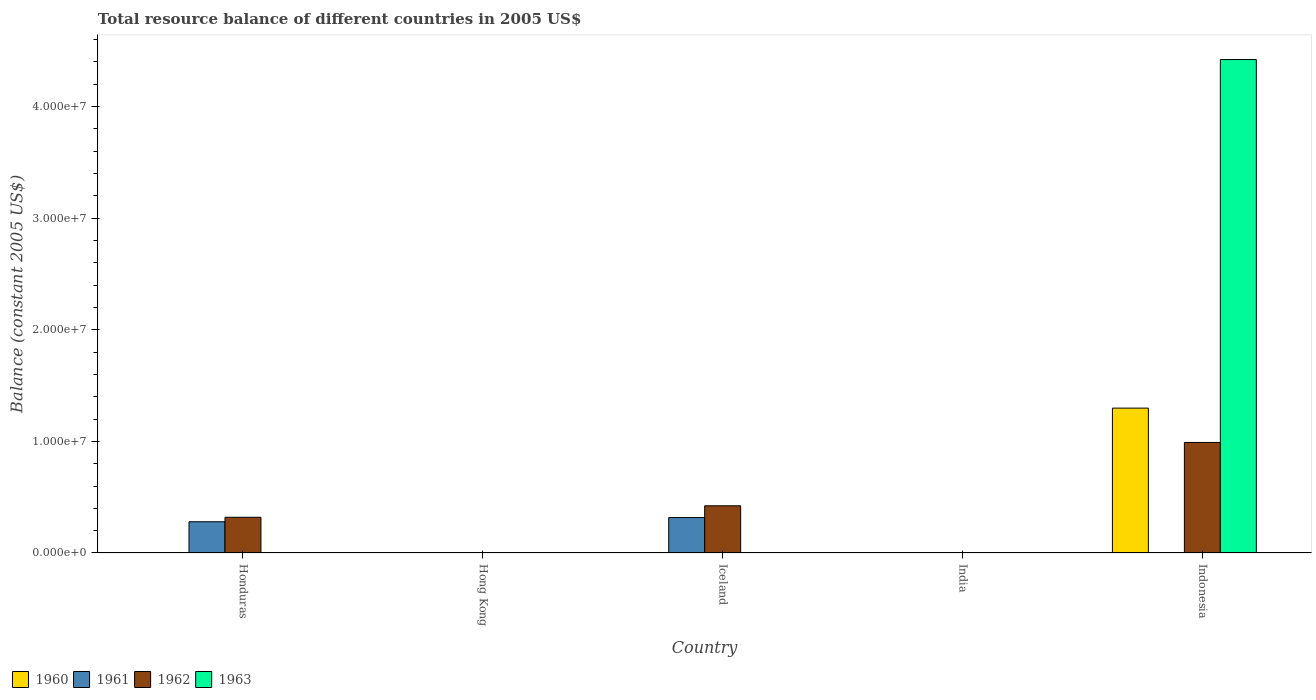How many different coloured bars are there?
Provide a short and direct response. 4. Are the number of bars per tick equal to the number of legend labels?
Ensure brevity in your answer.  No. How many bars are there on the 4th tick from the left?
Your answer should be compact. 0. What is the label of the 5th group of bars from the left?
Offer a very short reply. Indonesia. In how many cases, is the number of bars for a given country not equal to the number of legend labels?
Your response must be concise. 5. What is the total resource balance in 1961 in Honduras?
Give a very brief answer. 2.80e+06. Across all countries, what is the maximum total resource balance in 1960?
Your answer should be compact. 1.30e+07. What is the total total resource balance in 1960 in the graph?
Your response must be concise. 1.30e+07. What is the difference between the total resource balance in 1962 in Honduras and that in Indonesia?
Your response must be concise. -6.70e+06. What is the difference between the total resource balance in 1962 in Indonesia and the total resource balance in 1961 in Honduras?
Provide a short and direct response. 7.10e+06. What is the average total resource balance in 1961 per country?
Your response must be concise. 1.19e+06. What is the difference between the total resource balance of/in 1960 and total resource balance of/in 1962 in Indonesia?
Provide a short and direct response. 3.08e+06. Is the total resource balance in 1962 in Iceland less than that in Indonesia?
Offer a terse response. Yes. What is the difference between the highest and the second highest total resource balance in 1962?
Keep it short and to the point. 5.68e+06. What is the difference between the highest and the lowest total resource balance in 1962?
Your answer should be very brief. 9.90e+06. Is it the case that in every country, the sum of the total resource balance in 1961 and total resource balance in 1960 is greater than the total resource balance in 1963?
Provide a succinct answer. No. How many bars are there?
Provide a short and direct response. 7. Are all the bars in the graph horizontal?
Provide a short and direct response. No. Does the graph contain any zero values?
Provide a short and direct response. Yes. Where does the legend appear in the graph?
Make the answer very short. Bottom left. How many legend labels are there?
Offer a very short reply. 4. What is the title of the graph?
Keep it short and to the point. Total resource balance of different countries in 2005 US$. What is the label or title of the Y-axis?
Provide a short and direct response. Balance (constant 2005 US$). What is the Balance (constant 2005 US$) in 1960 in Honduras?
Make the answer very short. 0. What is the Balance (constant 2005 US$) of 1961 in Honduras?
Give a very brief answer. 2.80e+06. What is the Balance (constant 2005 US$) of 1962 in Honduras?
Provide a short and direct response. 3.20e+06. What is the Balance (constant 2005 US$) in 1961 in Hong Kong?
Your answer should be very brief. 0. What is the Balance (constant 2005 US$) of 1962 in Hong Kong?
Your response must be concise. 0. What is the Balance (constant 2005 US$) of 1963 in Hong Kong?
Ensure brevity in your answer.  0. What is the Balance (constant 2005 US$) of 1961 in Iceland?
Your answer should be compact. 3.17e+06. What is the Balance (constant 2005 US$) of 1962 in Iceland?
Keep it short and to the point. 4.23e+06. What is the Balance (constant 2005 US$) in 1963 in Iceland?
Give a very brief answer. 0. What is the Balance (constant 2005 US$) in 1960 in India?
Your answer should be very brief. 0. What is the Balance (constant 2005 US$) of 1961 in India?
Your answer should be very brief. 0. What is the Balance (constant 2005 US$) of 1962 in India?
Your response must be concise. 0. What is the Balance (constant 2005 US$) in 1963 in India?
Your answer should be compact. 0. What is the Balance (constant 2005 US$) of 1960 in Indonesia?
Provide a short and direct response. 1.30e+07. What is the Balance (constant 2005 US$) of 1961 in Indonesia?
Provide a short and direct response. 0. What is the Balance (constant 2005 US$) of 1962 in Indonesia?
Your response must be concise. 9.90e+06. What is the Balance (constant 2005 US$) in 1963 in Indonesia?
Make the answer very short. 4.42e+07. Across all countries, what is the maximum Balance (constant 2005 US$) of 1960?
Your answer should be very brief. 1.30e+07. Across all countries, what is the maximum Balance (constant 2005 US$) of 1961?
Your answer should be very brief. 3.17e+06. Across all countries, what is the maximum Balance (constant 2005 US$) of 1962?
Make the answer very short. 9.90e+06. Across all countries, what is the maximum Balance (constant 2005 US$) in 1963?
Offer a very short reply. 4.42e+07. Across all countries, what is the minimum Balance (constant 2005 US$) of 1960?
Give a very brief answer. 0. Across all countries, what is the minimum Balance (constant 2005 US$) in 1963?
Make the answer very short. 0. What is the total Balance (constant 2005 US$) of 1960 in the graph?
Your answer should be very brief. 1.30e+07. What is the total Balance (constant 2005 US$) of 1961 in the graph?
Give a very brief answer. 5.97e+06. What is the total Balance (constant 2005 US$) of 1962 in the graph?
Your answer should be compact. 1.73e+07. What is the total Balance (constant 2005 US$) in 1963 in the graph?
Give a very brief answer. 4.42e+07. What is the difference between the Balance (constant 2005 US$) of 1961 in Honduras and that in Iceland?
Offer a terse response. -3.74e+05. What is the difference between the Balance (constant 2005 US$) of 1962 in Honduras and that in Iceland?
Give a very brief answer. -1.03e+06. What is the difference between the Balance (constant 2005 US$) of 1962 in Honduras and that in Indonesia?
Keep it short and to the point. -6.70e+06. What is the difference between the Balance (constant 2005 US$) in 1962 in Iceland and that in Indonesia?
Provide a succinct answer. -5.68e+06. What is the difference between the Balance (constant 2005 US$) of 1961 in Honduras and the Balance (constant 2005 US$) of 1962 in Iceland?
Offer a terse response. -1.43e+06. What is the difference between the Balance (constant 2005 US$) of 1961 in Honduras and the Balance (constant 2005 US$) of 1962 in Indonesia?
Your answer should be very brief. -7.10e+06. What is the difference between the Balance (constant 2005 US$) in 1961 in Honduras and the Balance (constant 2005 US$) in 1963 in Indonesia?
Offer a very short reply. -4.14e+07. What is the difference between the Balance (constant 2005 US$) of 1962 in Honduras and the Balance (constant 2005 US$) of 1963 in Indonesia?
Ensure brevity in your answer.  -4.10e+07. What is the difference between the Balance (constant 2005 US$) of 1961 in Iceland and the Balance (constant 2005 US$) of 1962 in Indonesia?
Give a very brief answer. -6.73e+06. What is the difference between the Balance (constant 2005 US$) of 1961 in Iceland and the Balance (constant 2005 US$) of 1963 in Indonesia?
Provide a succinct answer. -4.10e+07. What is the difference between the Balance (constant 2005 US$) in 1962 in Iceland and the Balance (constant 2005 US$) in 1963 in Indonesia?
Your answer should be very brief. -4.00e+07. What is the average Balance (constant 2005 US$) of 1960 per country?
Make the answer very short. 2.60e+06. What is the average Balance (constant 2005 US$) in 1961 per country?
Ensure brevity in your answer.  1.19e+06. What is the average Balance (constant 2005 US$) of 1962 per country?
Offer a terse response. 3.47e+06. What is the average Balance (constant 2005 US$) in 1963 per country?
Ensure brevity in your answer.  8.84e+06. What is the difference between the Balance (constant 2005 US$) of 1961 and Balance (constant 2005 US$) of 1962 in Honduras?
Give a very brief answer. -4.00e+05. What is the difference between the Balance (constant 2005 US$) in 1961 and Balance (constant 2005 US$) in 1962 in Iceland?
Provide a short and direct response. -1.05e+06. What is the difference between the Balance (constant 2005 US$) of 1960 and Balance (constant 2005 US$) of 1962 in Indonesia?
Your answer should be very brief. 3.08e+06. What is the difference between the Balance (constant 2005 US$) of 1960 and Balance (constant 2005 US$) of 1963 in Indonesia?
Ensure brevity in your answer.  -3.12e+07. What is the difference between the Balance (constant 2005 US$) in 1962 and Balance (constant 2005 US$) in 1963 in Indonesia?
Provide a succinct answer. -3.43e+07. What is the ratio of the Balance (constant 2005 US$) in 1961 in Honduras to that in Iceland?
Give a very brief answer. 0.88. What is the ratio of the Balance (constant 2005 US$) in 1962 in Honduras to that in Iceland?
Ensure brevity in your answer.  0.76. What is the ratio of the Balance (constant 2005 US$) in 1962 in Honduras to that in Indonesia?
Provide a succinct answer. 0.32. What is the ratio of the Balance (constant 2005 US$) of 1962 in Iceland to that in Indonesia?
Your response must be concise. 0.43. What is the difference between the highest and the second highest Balance (constant 2005 US$) of 1962?
Offer a very short reply. 5.68e+06. What is the difference between the highest and the lowest Balance (constant 2005 US$) of 1960?
Offer a very short reply. 1.30e+07. What is the difference between the highest and the lowest Balance (constant 2005 US$) of 1961?
Provide a succinct answer. 3.17e+06. What is the difference between the highest and the lowest Balance (constant 2005 US$) of 1962?
Offer a very short reply. 9.90e+06. What is the difference between the highest and the lowest Balance (constant 2005 US$) in 1963?
Keep it short and to the point. 4.42e+07. 